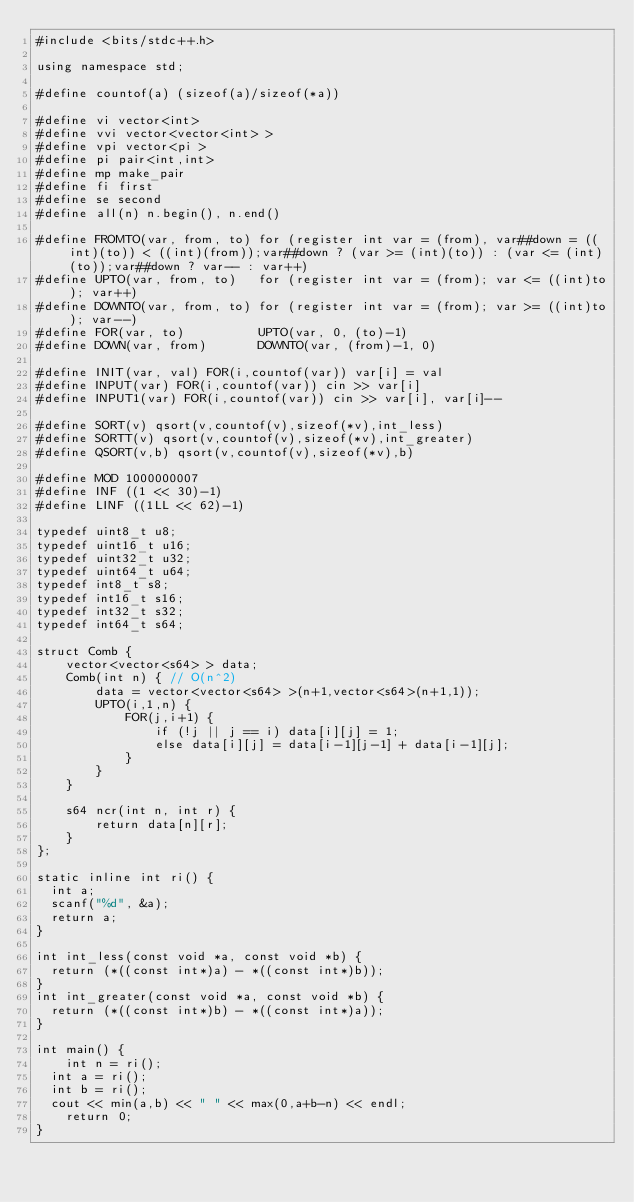<code> <loc_0><loc_0><loc_500><loc_500><_C++_>#include <bits/stdc++.h>

using namespace std;

#define countof(a) (sizeof(a)/sizeof(*a))

#define vi vector<int>
#define vvi vector<vector<int> >
#define vpi vector<pi >
#define pi pair<int,int>
#define mp make_pair
#define fi first
#define se second
#define all(n) n.begin(), n.end()

#define FROMTO(var, from, to) for (register int var = (from), var##down = ((int)(to)) < ((int)(from));var##down ? (var >= (int)(to)) : (var <= (int)(to));var##down ? var-- : var++)
#define UPTO(var, from, to)   for (register int var = (from); var <= ((int)to); var++)
#define DOWNTO(var, from, to) for (register int var = (from); var >= ((int)to); var--)
#define FOR(var, to)          UPTO(var, 0, (to)-1)
#define DOWN(var, from)       DOWNTO(var, (from)-1, 0)

#define INIT(var, val) FOR(i,countof(var)) var[i] = val
#define INPUT(var) FOR(i,countof(var)) cin >> var[i]
#define INPUT1(var) FOR(i,countof(var)) cin >> var[i], var[i]--

#define SORT(v) qsort(v,countof(v),sizeof(*v),int_less)
#define SORTT(v) qsort(v,countof(v),sizeof(*v),int_greater)
#define QSORT(v,b) qsort(v,countof(v),sizeof(*v),b)

#define MOD 1000000007
#define INF ((1 << 30)-1)
#define LINF ((1LL << 62)-1)

typedef uint8_t u8;
typedef uint16_t u16;
typedef uint32_t u32;
typedef uint64_t u64;
typedef int8_t s8;
typedef int16_t s16;
typedef int32_t s32;
typedef int64_t s64;

struct Comb {
    vector<vector<s64> > data;
    Comb(int n) { // O(n^2)
        data = vector<vector<s64> >(n+1,vector<s64>(n+1,1));
        UPTO(i,1,n) {
            FOR(j,i+1) {
                if (!j || j == i) data[i][j] = 1;
                else data[i][j] = data[i-1][j-1] + data[i-1][j];
            }
        }
    }

    s64 ncr(int n, int r) {
        return data[n][r];
    }
};

static inline int ri() {
  int a;
  scanf("%d", &a);
  return a;
}

int int_less(const void *a, const void *b) {
  return (*((const int*)a) - *((const int*)b));
}
int int_greater(const void *a, const void *b) {
  return (*((const int*)b) - *((const int*)a));
}

int main() {
    int n = ri();
	int a = ri();
	int b = ri();
	cout << min(a,b) << " " << max(0,a+b-n) << endl;
    return 0;
}
</code> 